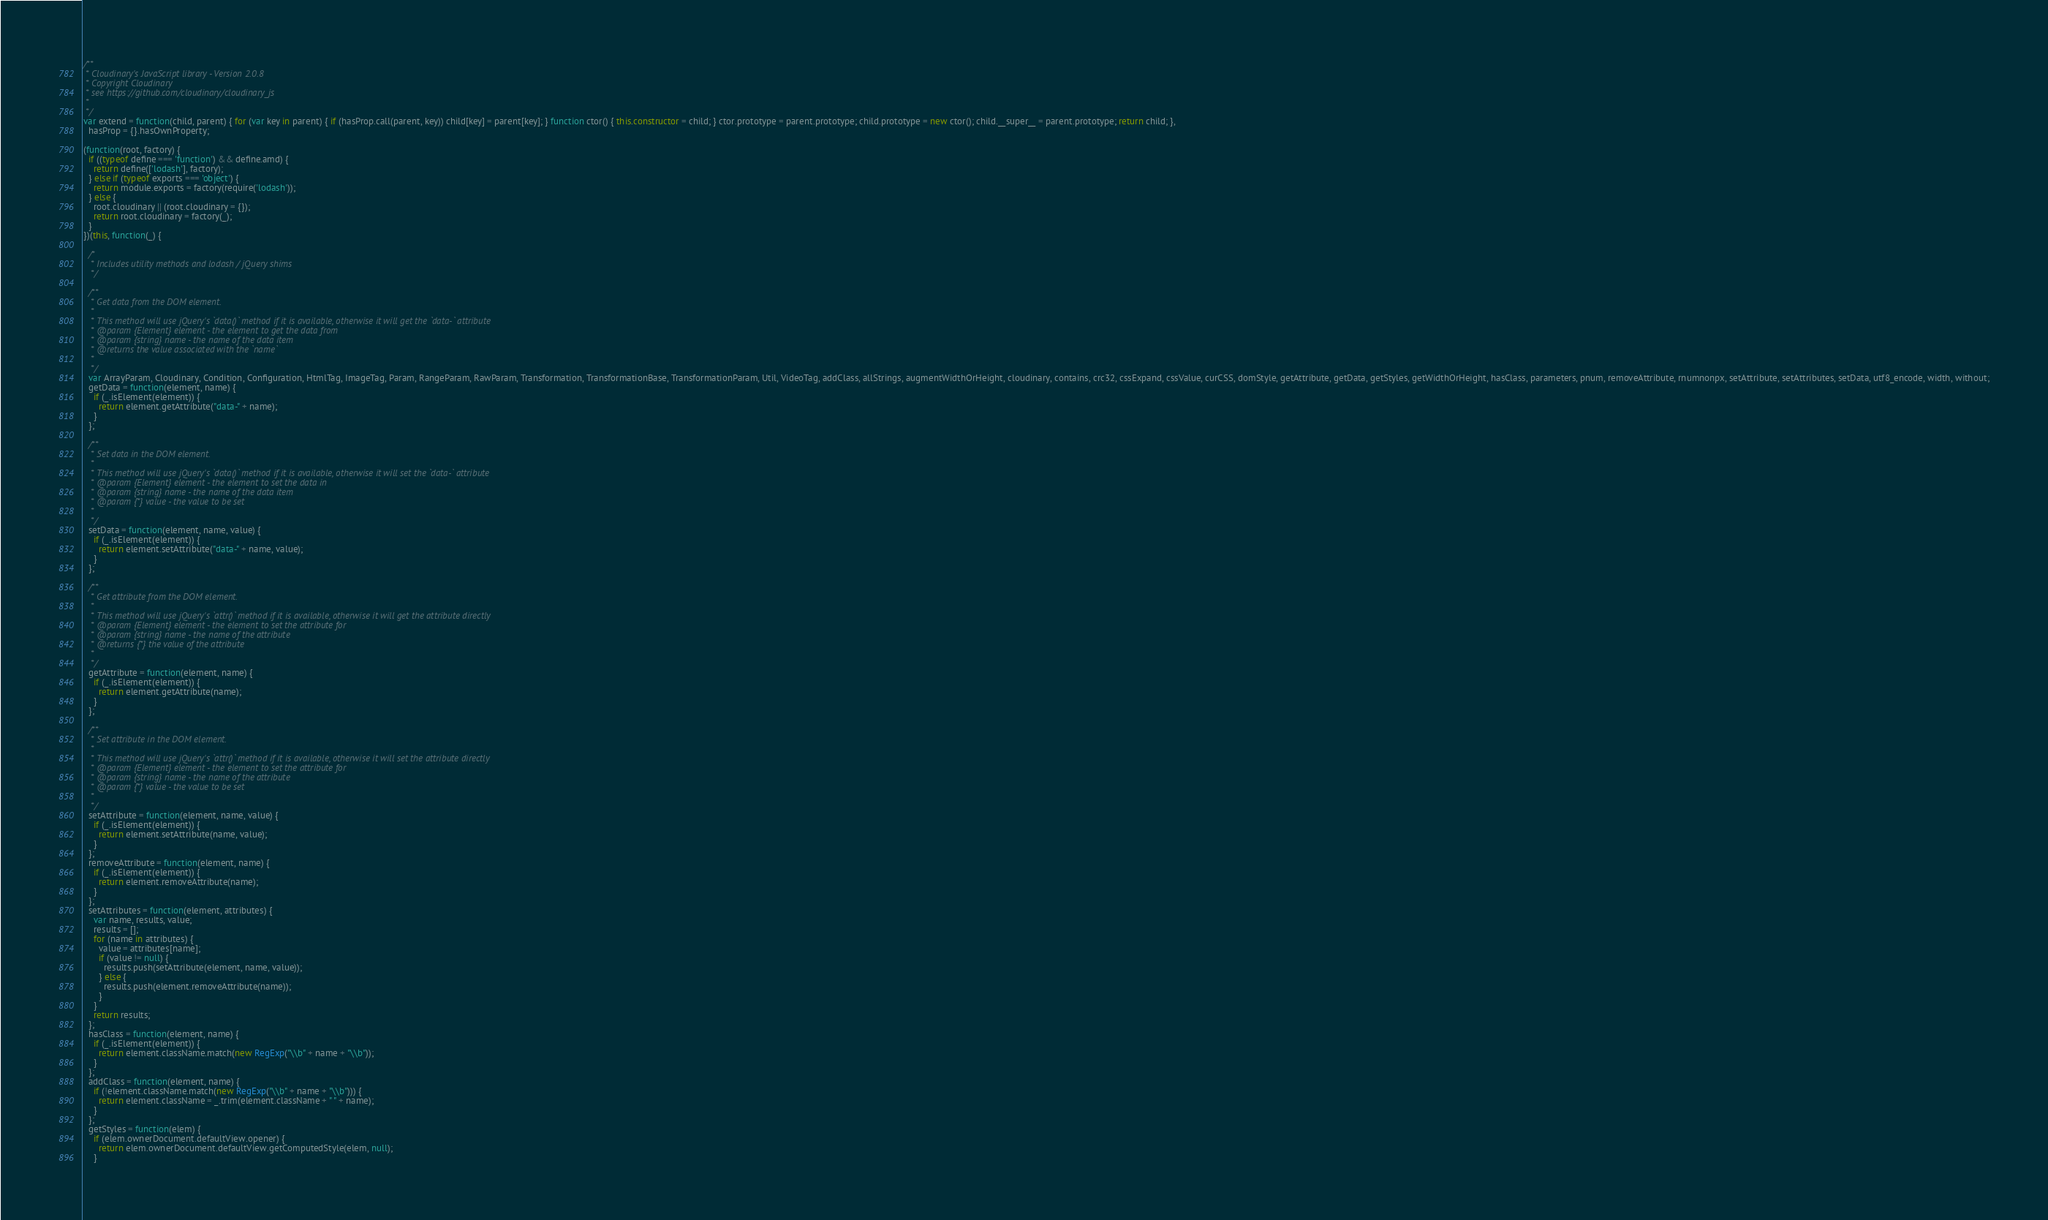Convert code to text. <code><loc_0><loc_0><loc_500><loc_500><_JavaScript_>
/**
 * Cloudinary's JavaScript library - Version 2.0.8
 * Copyright Cloudinary
 * see https://github.com/cloudinary/cloudinary_js
 *
 */
var extend = function(child, parent) { for (var key in parent) { if (hasProp.call(parent, key)) child[key] = parent[key]; } function ctor() { this.constructor = child; } ctor.prototype = parent.prototype; child.prototype = new ctor(); child.__super__ = parent.prototype; return child; },
  hasProp = {}.hasOwnProperty;

(function(root, factory) {
  if ((typeof define === 'function') && define.amd) {
    return define(['lodash'], factory);
  } else if (typeof exports === 'object') {
    return module.exports = factory(require('lodash'));
  } else {
    root.cloudinary || (root.cloudinary = {});
    return root.cloudinary = factory(_);
  }
})(this, function(_) {

  /*
   * Includes utility methods and lodash / jQuery shims
   */

  /**
   * Get data from the DOM element.
   *
   * This method will use jQuery's `data()` method if it is available, otherwise it will get the `data-` attribute
   * @param {Element} element - the element to get the data from
   * @param {string} name - the name of the data item
   * @returns the value associated with the `name`
   *
   */
  var ArrayParam, Cloudinary, Condition, Configuration, HtmlTag, ImageTag, Param, RangeParam, RawParam, Transformation, TransformationBase, TransformationParam, Util, VideoTag, addClass, allStrings, augmentWidthOrHeight, cloudinary, contains, crc32, cssExpand, cssValue, curCSS, domStyle, getAttribute, getData, getStyles, getWidthOrHeight, hasClass, parameters, pnum, removeAttribute, rnumnonpx, setAttribute, setAttributes, setData, utf8_encode, width, without;
  getData = function(element, name) {
    if (_.isElement(element)) {
      return element.getAttribute("data-" + name);
    }
  };

  /**
   * Set data in the DOM element.
   *
   * This method will use jQuery's `data()` method if it is available, otherwise it will set the `data-` attribute
   * @param {Element} element - the element to set the data in
   * @param {string} name - the name of the data item
   * @param {*} value - the value to be set
   *
   */
  setData = function(element, name, value) {
    if (_.isElement(element)) {
      return element.setAttribute("data-" + name, value);
    }
  };

  /**
   * Get attribute from the DOM element.
   *
   * This method will use jQuery's `attr()` method if it is available, otherwise it will get the attribute directly
   * @param {Element} element - the element to set the attribute for
   * @param {string} name - the name of the attribute
   * @returns {*} the value of the attribute
   *
   */
  getAttribute = function(element, name) {
    if (_.isElement(element)) {
      return element.getAttribute(name);
    }
  };

  /**
   * Set attribute in the DOM element.
   *
   * This method will use jQuery's `attr()` method if it is available, otherwise it will set the attribute directly
   * @param {Element} element - the element to set the attribute for
   * @param {string} name - the name of the attribute
   * @param {*} value - the value to be set
   *
   */
  setAttribute = function(element, name, value) {
    if (_.isElement(element)) {
      return element.setAttribute(name, value);
    }
  };
  removeAttribute = function(element, name) {
    if (_.isElement(element)) {
      return element.removeAttribute(name);
    }
  };
  setAttributes = function(element, attributes) {
    var name, results, value;
    results = [];
    for (name in attributes) {
      value = attributes[name];
      if (value != null) {
        results.push(setAttribute(element, name, value));
      } else {
        results.push(element.removeAttribute(name));
      }
    }
    return results;
  };
  hasClass = function(element, name) {
    if (_.isElement(element)) {
      return element.className.match(new RegExp("\\b" + name + "\\b"));
    }
  };
  addClass = function(element, name) {
    if (!element.className.match(new RegExp("\\b" + name + "\\b"))) {
      return element.className = _.trim(element.className + " " + name);
    }
  };
  getStyles = function(elem) {
    if (elem.ownerDocument.defaultView.opener) {
      return elem.ownerDocument.defaultView.getComputedStyle(elem, null);
    }</code> 